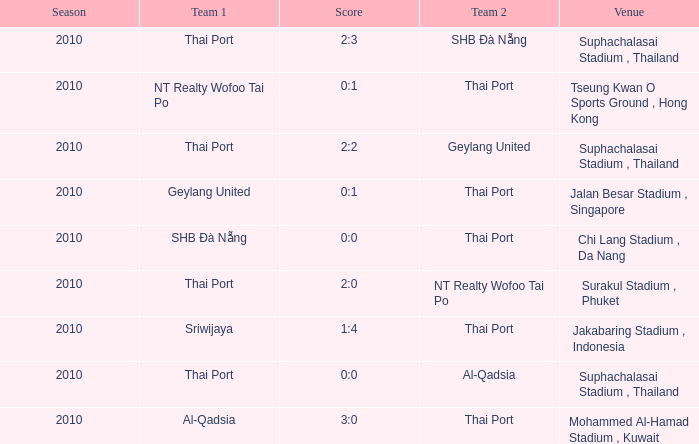Which venue was used for the game whose score was 2:3? Suphachalasai Stadium , Thailand. 